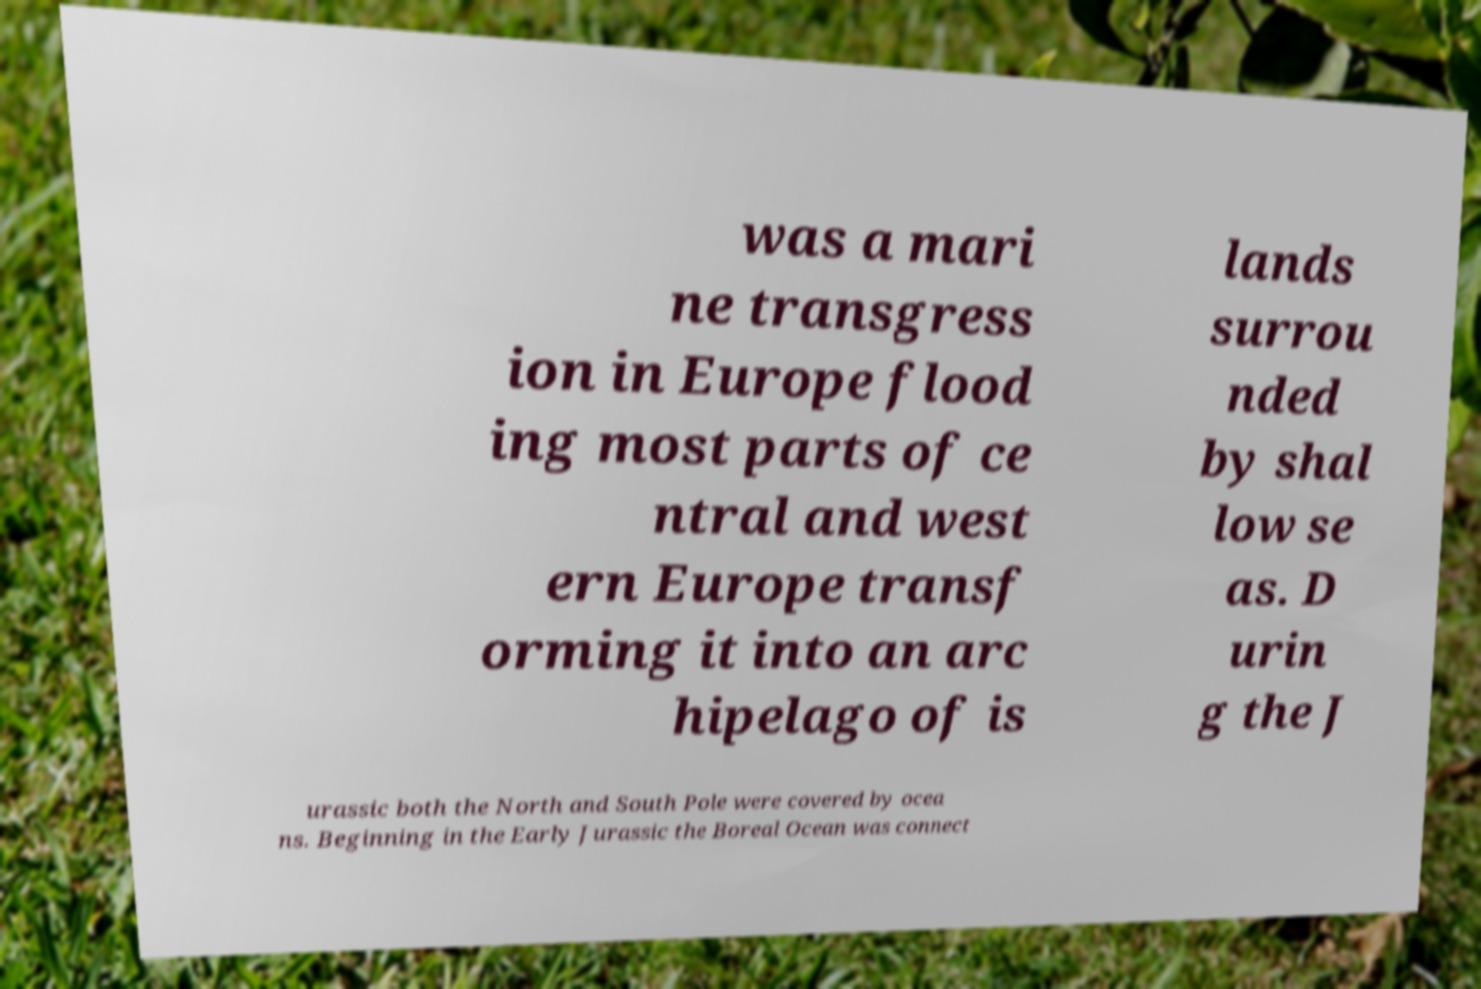Can you read and provide the text displayed in the image?This photo seems to have some interesting text. Can you extract and type it out for me? was a mari ne transgress ion in Europe flood ing most parts of ce ntral and west ern Europe transf orming it into an arc hipelago of is lands surrou nded by shal low se as. D urin g the J urassic both the North and South Pole were covered by ocea ns. Beginning in the Early Jurassic the Boreal Ocean was connect 